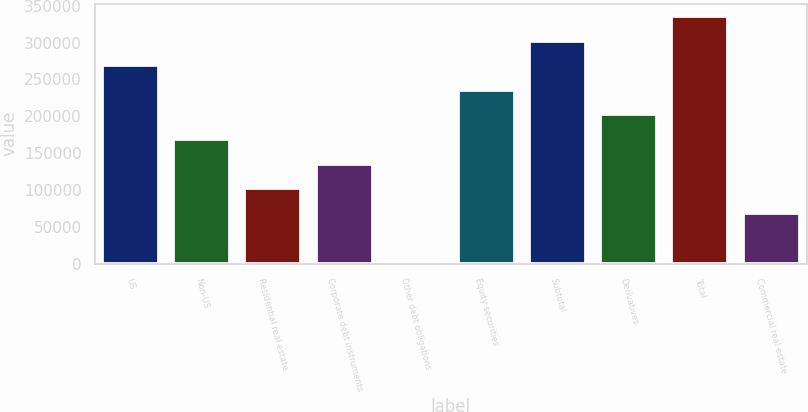Convert chart. <chart><loc_0><loc_0><loc_500><loc_500><bar_chart><fcel>US<fcel>Non-US<fcel>Residential real estate<fcel>Corporate debt instruments<fcel>Other debt obligations<fcel>Equity securities<fcel>Subtotal<fcel>Derivatives<fcel>Total<fcel>Commercial real estate<nl><fcel>269302<fcel>169012<fcel>102153<fcel>135583<fcel>1864<fcel>235872<fcel>302731<fcel>202442<fcel>336161<fcel>68723.4<nl></chart> 